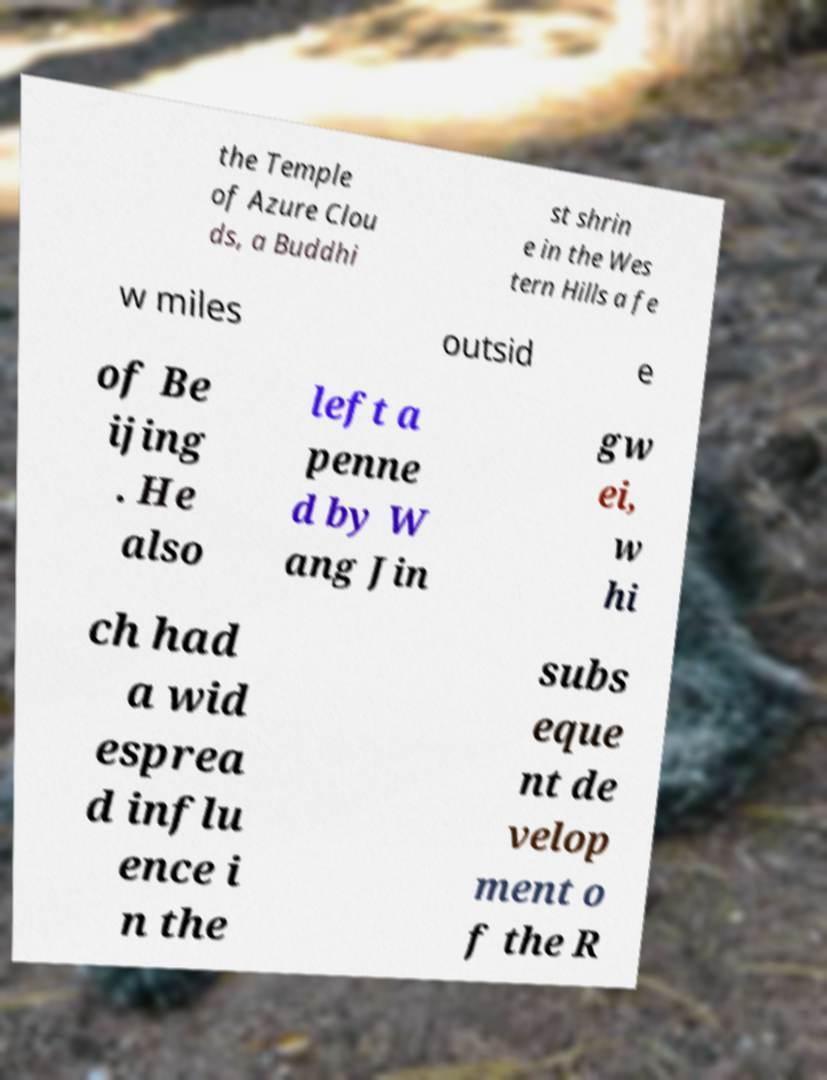For documentation purposes, I need the text within this image transcribed. Could you provide that? the Temple of Azure Clou ds, a Buddhi st shrin e in the Wes tern Hills a fe w miles outsid e of Be ijing . He also left a penne d by W ang Jin gw ei, w hi ch had a wid esprea d influ ence i n the subs eque nt de velop ment o f the R 